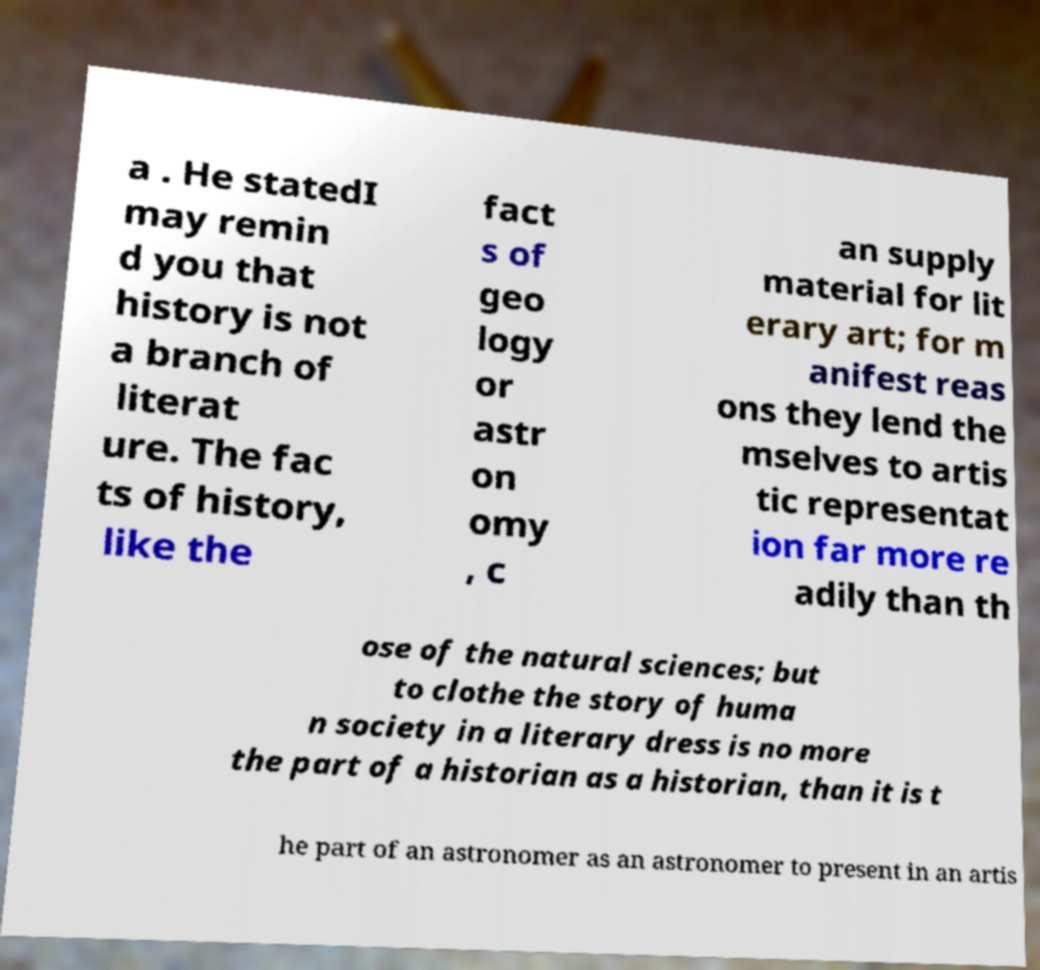There's text embedded in this image that I need extracted. Can you transcribe it verbatim? a . He statedI may remin d you that history is not a branch of literat ure. The fac ts of history, like the fact s of geo logy or astr on omy , c an supply material for lit erary art; for m anifest reas ons they lend the mselves to artis tic representat ion far more re adily than th ose of the natural sciences; but to clothe the story of huma n society in a literary dress is no more the part of a historian as a historian, than it is t he part of an astronomer as an astronomer to present in an artis 